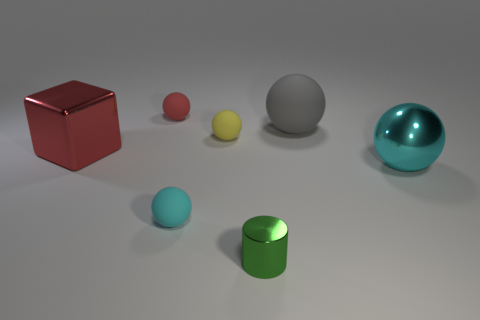Subtract all yellow rubber balls. How many balls are left? 4 Add 1 big purple rubber objects. How many objects exist? 8 Subtract all yellow spheres. How many spheres are left? 4 Subtract all green spheres. How many blue cubes are left? 0 Subtract all spheres. How many objects are left? 2 Subtract all blue cylinders. Subtract all red cubes. How many cylinders are left? 1 Subtract all small yellow objects. Subtract all tiny green things. How many objects are left? 5 Add 6 yellow matte spheres. How many yellow matte spheres are left? 7 Add 6 tiny brown rubber cylinders. How many tiny brown rubber cylinders exist? 6 Subtract 1 gray spheres. How many objects are left? 6 